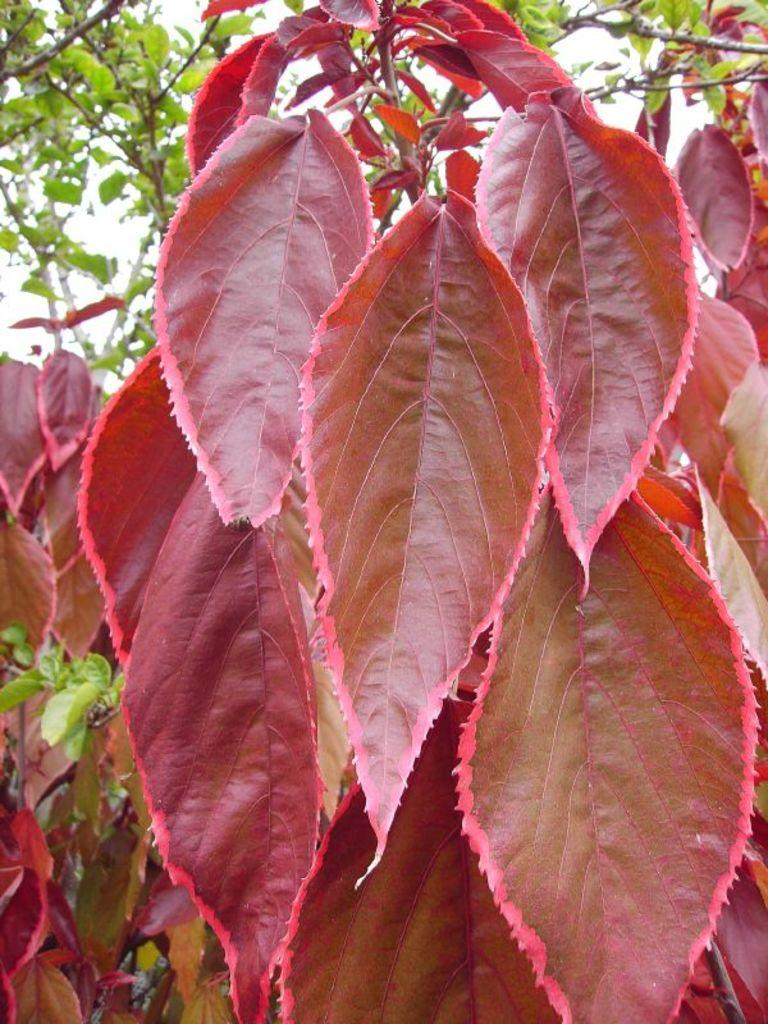What is in the foreground of the image? There are leaves and a stem in the foreground of the image. What can be seen in the background of the image? There are trees in the background of the image. How would you describe the sky in the image? The sky is cloudy in the image. What type of skin is visible on the leaves in the image? There is no skin visible on the leaves in the image; they are made of plant material. Can you see a balloon in the image? There is no balloon present in the image. 